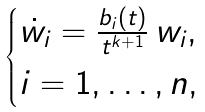Convert formula to latex. <formula><loc_0><loc_0><loc_500><loc_500>\begin{cases} \dot { w _ { i } } = \frac { b _ { i } ( t ) } { t ^ { k + 1 } } \, w _ { i } , \\ i = 1 , \dots , n , \end{cases}</formula> 